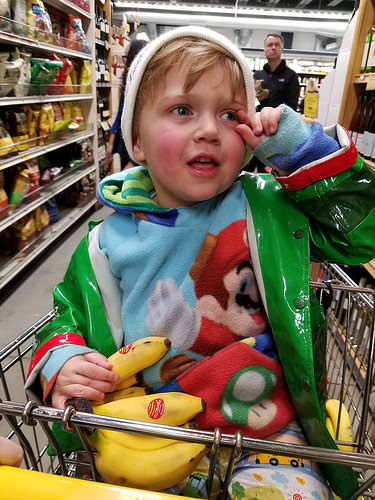<image>
Is the banana on the boy? Yes. Looking at the image, I can see the banana is positioned on top of the boy, with the boy providing support. Is the banana on the baby? Yes. Looking at the image, I can see the banana is positioned on top of the baby, with the baby providing support. Is the man behind the child? Yes. From this viewpoint, the man is positioned behind the child, with the child partially or fully occluding the man. 